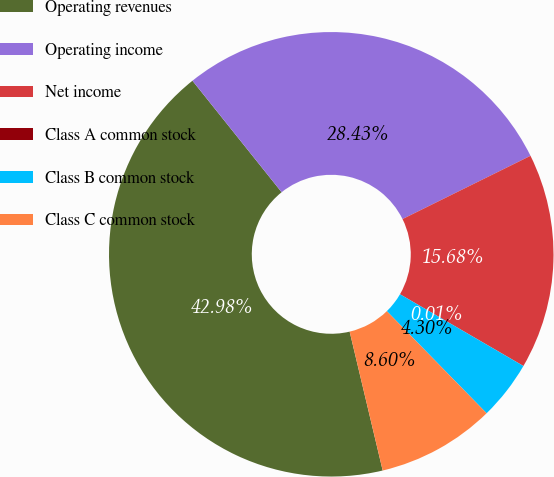<chart> <loc_0><loc_0><loc_500><loc_500><pie_chart><fcel>Operating revenues<fcel>Operating income<fcel>Net income<fcel>Class A common stock<fcel>Class B common stock<fcel>Class C common stock<nl><fcel>42.98%<fcel>28.43%<fcel>15.68%<fcel>0.01%<fcel>4.3%<fcel>8.6%<nl></chart> 